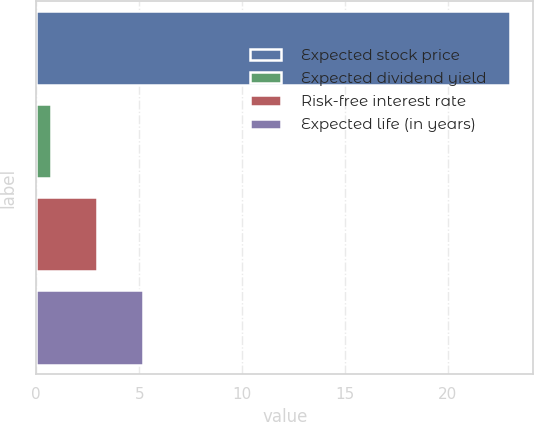<chart> <loc_0><loc_0><loc_500><loc_500><bar_chart><fcel>Expected stock price<fcel>Expected dividend yield<fcel>Risk-free interest rate<fcel>Expected life (in years)<nl><fcel>23<fcel>0.7<fcel>2.93<fcel>5.16<nl></chart> 